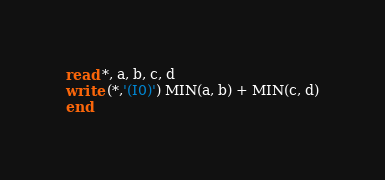Convert code to text. <code><loc_0><loc_0><loc_500><loc_500><_FORTRAN_>read *, a, b, c, d
write (*,'(I0)') MIN(a, b) + MIN(c, d)
end</code> 